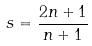<formula> <loc_0><loc_0><loc_500><loc_500>s = \frac { 2 n + 1 } { n + 1 }</formula> 